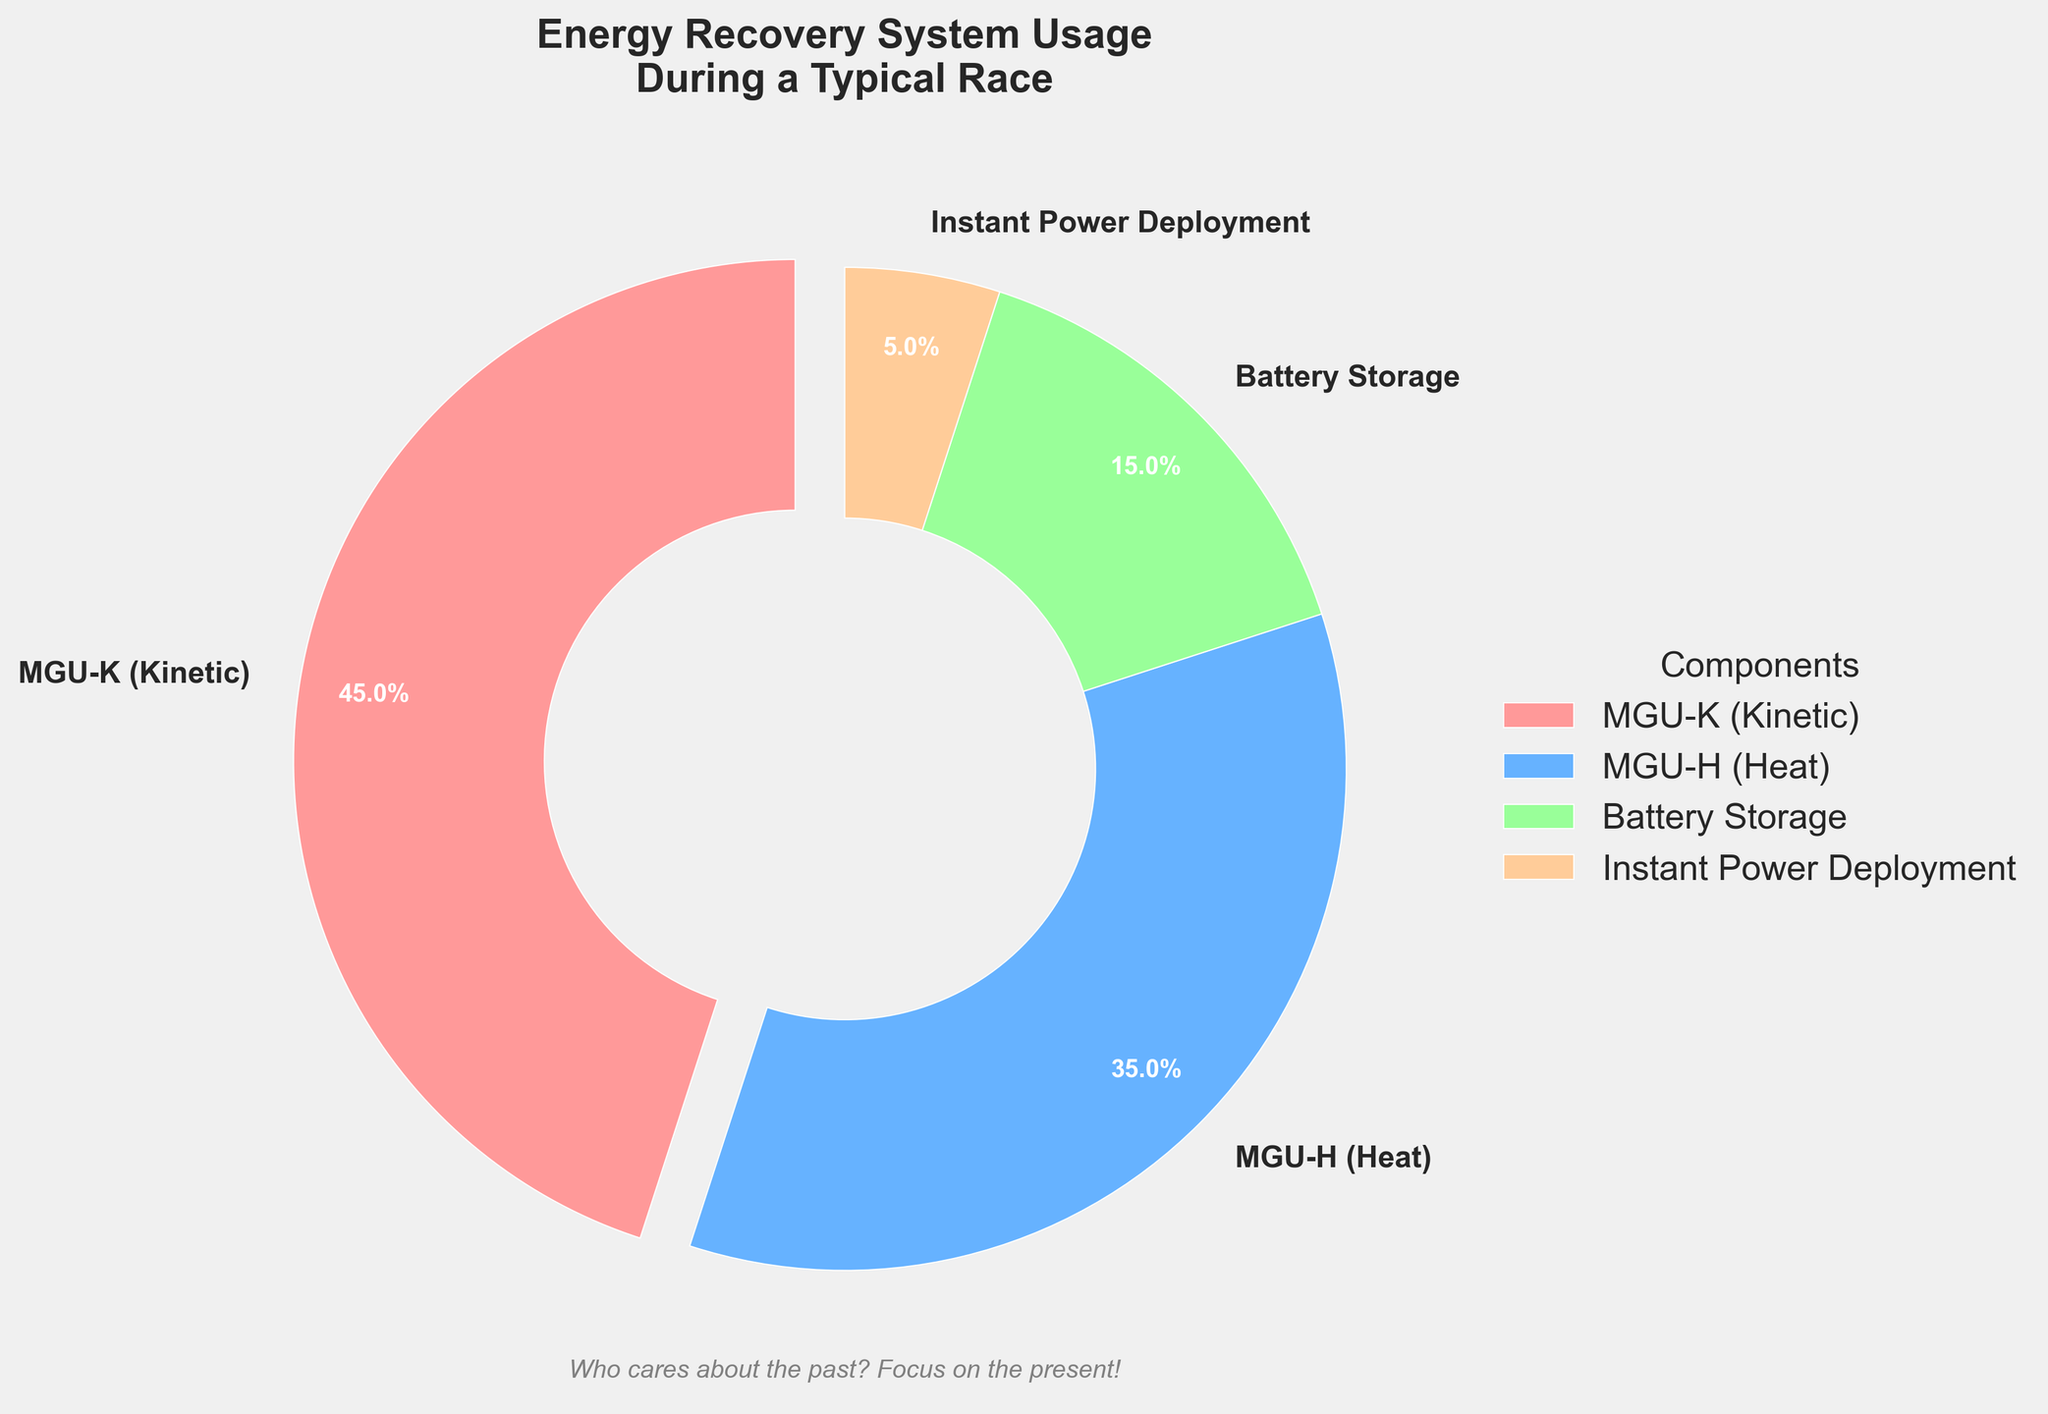What percentage of energy is recovered by the MGU-K system? The figure shows the percentage of energy recovered by different components. By identifying the MGU-K section on the pie chart, we can see it's marked as 45%.
Answer: 45% Which energy recovery component has the smallest usage percentage? Examine the pie chart and compare the percentages of each component. The smallest percentage is labeled as "Instant Power Deployment" with 5%.
Answer: Instant Power Deployment What is the combined percentage of energy recovered by the MGU-K and Battery Storage systems? Add the percentages from the MGU-K and Battery Storage sections. MGU-K is 45% and Battery Storage is 15%, so combined they make 60%.
Answer: 60% How much greater is the usage of the MGU-H system compared to the Instant Power Deployment system? Subtract the percentage of the Instant Power Deployment from the MGU-H. MGU-H is 35% and Instant Power Deployment is 5%, resulting in a difference of 30%.
Answer: 30% Which section of the pie chart is highlighted or exploded? Examine the visual attributes of the pie chart to identify which section stands out. The MGU-K section is exploded slightly from the rest of the chart.
Answer: MGU-K How do the percentages of the MGU-K and MGU-H systems compare? Compare the percentages shown for MGU-K and MGU-H. MGU-K is 45%, and MGU-H is 35%, so MGU-K is greater.
Answer: MGU-K is greater If the Battery Storage and Instant Power Deployment systems were combined into one category, what would their total percentage be? Add the percentages from Battery Storage and Instant Power Deployment. Battery Storage is 15% and Instant Power Deployment is 5%, totaling 20%.
Answer: 20% What does the subtitle of the chart emphasize? Read the subtitle visually presented below the pie chart. It states, "Who cares about the past? Focus on the present!" indicating a focus on the present.
Answer: Focus on the present What is the sum of all the percentages of the energy recovery components shown in the pie chart? Add the percentages from all four components: 45% (MGU-K) + 35% (MGU-H) + 15% (Battery Storage) + 5% (Instant Power Deployment) = 100%.
Answer: 100% What color represents the Battery Storage section on the pie chart? Identify the color associated with the Battery Storage section of the pie chart. It is shaded in green.
Answer: Green 